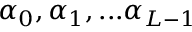Convert formula to latex. <formula><loc_0><loc_0><loc_500><loc_500>\alpha _ { 0 } , \alpha _ { 1 } , \dots \alpha _ { L - 1 }</formula> 